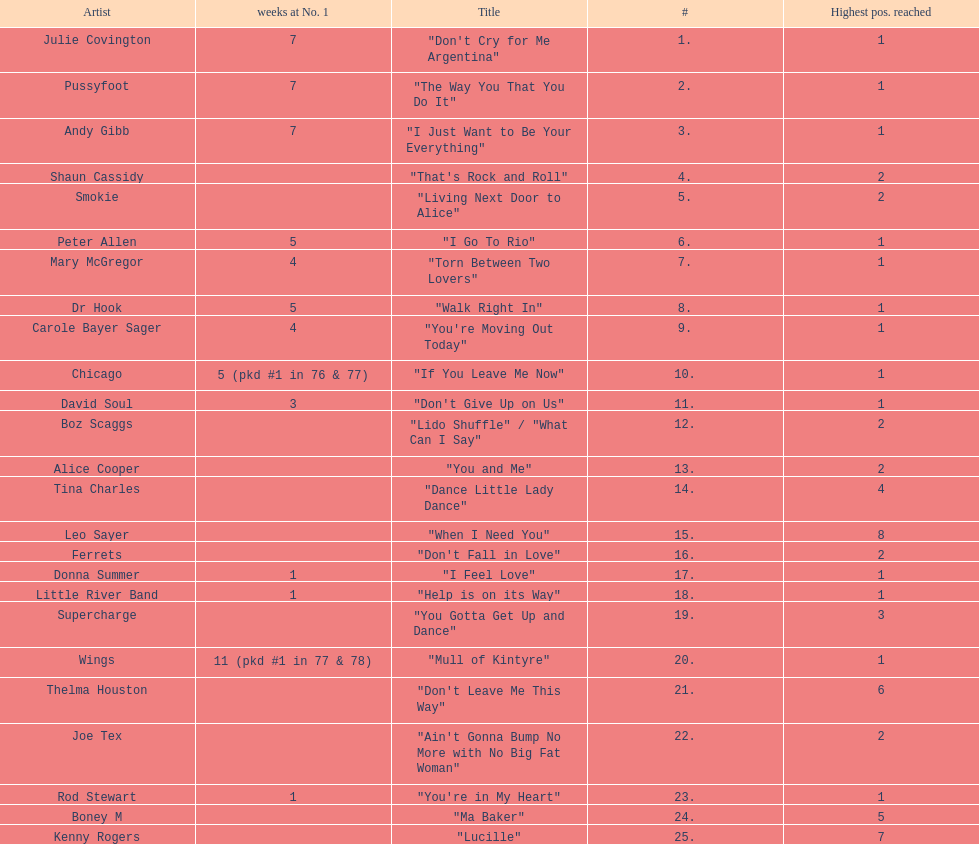Which song stayed at no.1 for the most amount of weeks. "Mull of Kintyre". 